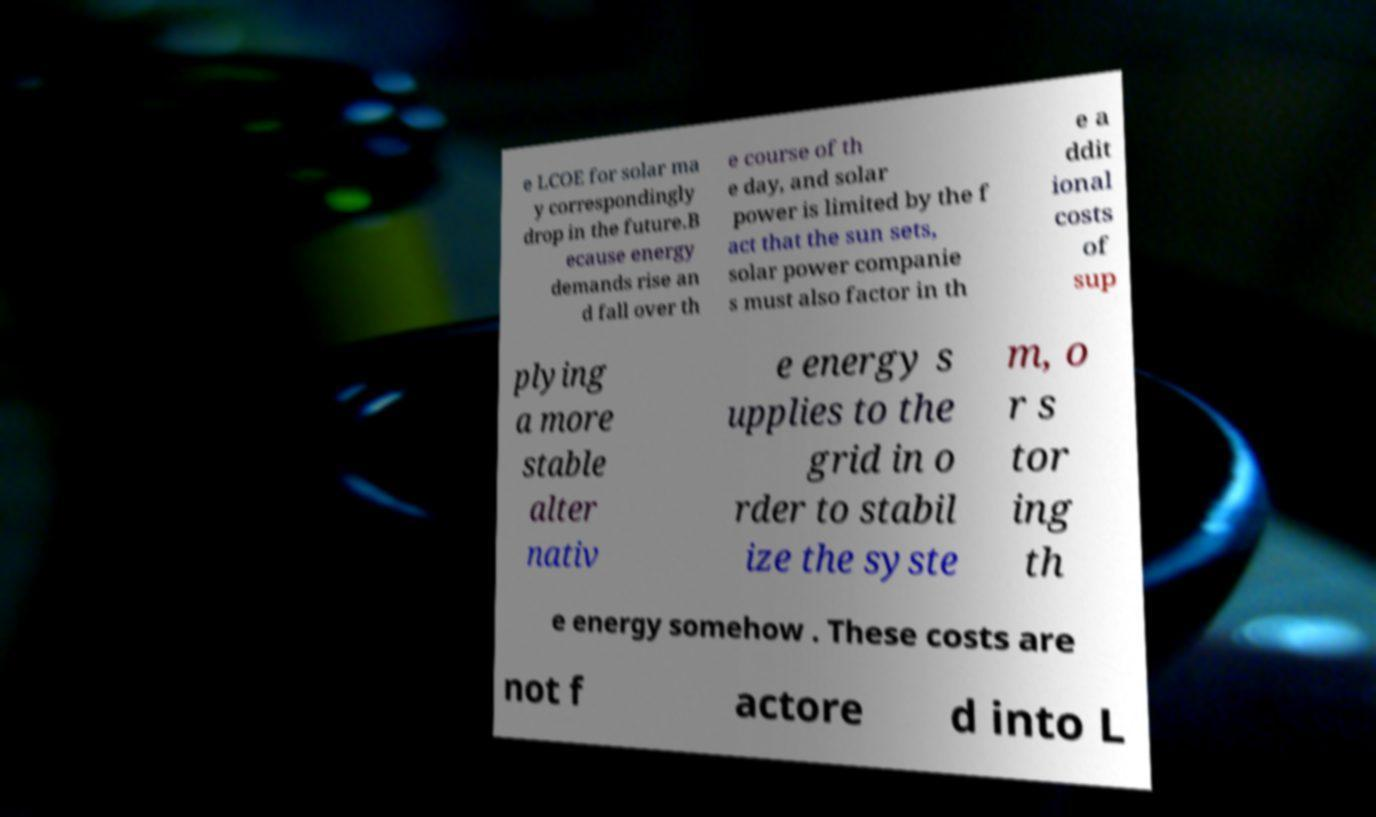There's text embedded in this image that I need extracted. Can you transcribe it verbatim? e LCOE for solar ma y correspondingly drop in the future.B ecause energy demands rise an d fall over th e course of th e day, and solar power is limited by the f act that the sun sets, solar power companie s must also factor in th e a ddit ional costs of sup plying a more stable alter nativ e energy s upplies to the grid in o rder to stabil ize the syste m, o r s tor ing th e energy somehow . These costs are not f actore d into L 